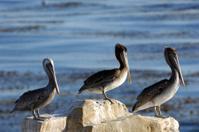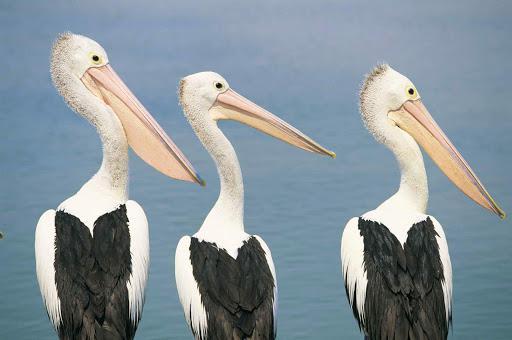The first image is the image on the left, the second image is the image on the right. Analyze the images presented: Is the assertion "Each image contains three left-facing pelicans posed in a row." valid? Answer yes or no. No. The first image is the image on the left, the second image is the image on the right. Analyze the images presented: Is the assertion "Three birds are perched on flat planks of a deck." valid? Answer yes or no. No. 